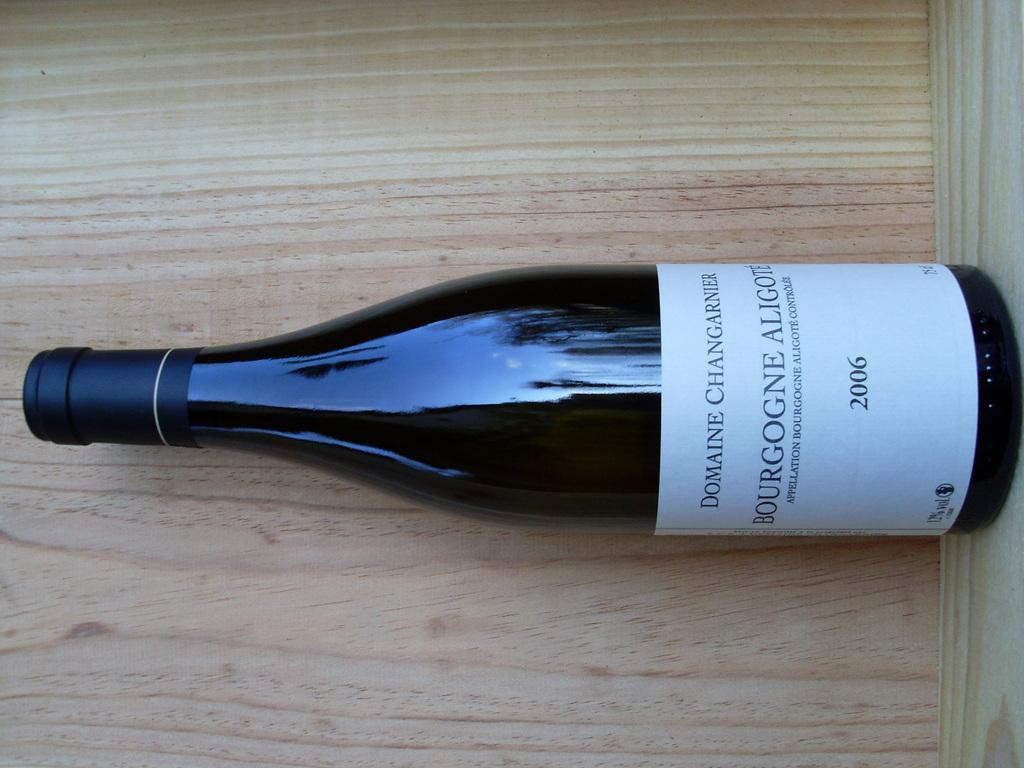Provide a one-sentence caption for the provided image. A bottle of a 2006 vintage wine produced by Domaine Changarnier rests on a wooden shelf. 